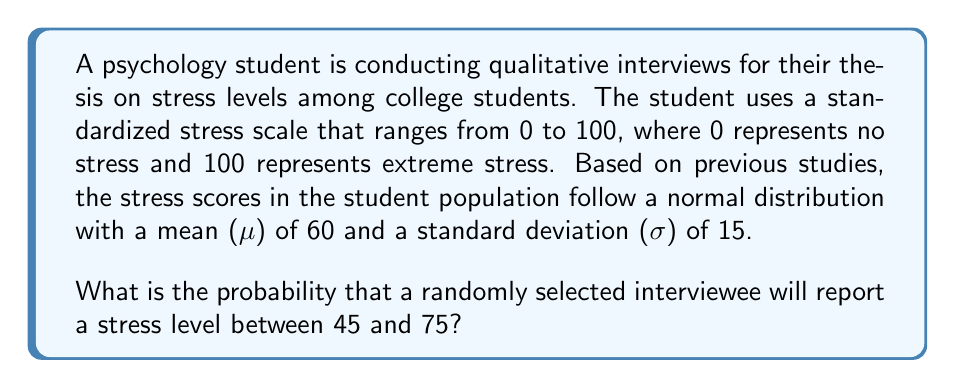Help me with this question. To solve this problem, we need to use the properties of the normal distribution and the concept of z-scores.

1. First, we need to calculate the z-scores for the lower and upper bounds of the given range:

   For x = 45: $z_1 = \frac{x - \mu}{\sigma} = \frac{45 - 60}{15} = -1$

   For x = 75: $z_2 = \frac{x - \mu}{\sigma} = \frac{75 - 60}{15} = 1$

2. Now, we need to find the area under the standard normal curve between these two z-scores. This area represents the probability we're looking for.

3. We can use the standard normal distribution table or a calculator to find the area between z = -1 and z = 1.

4. The area under the standard normal curve from the mean (z = 0) to any positive z-score is equal to the area from the negative of that z-score to the mean. This property is due to the symmetry of the normal distribution.

5. The area from z = 0 to z = 1 is approximately 0.3413.

6. Since we want the area from z = -1 to z = 1, we double this value:

   $P(-1 < Z < 1) = 2 * 0.3413 = 0.6826$

7. This means that approximately 68.26% of the data in a normal distribution falls within one standard deviation of the mean.

Therefore, the probability that a randomly selected interviewee will report a stress level between 45 and 75 is approximately 0.6826 or 68.26%.
Answer: The probability is approximately 0.6826 or 68.26%. 